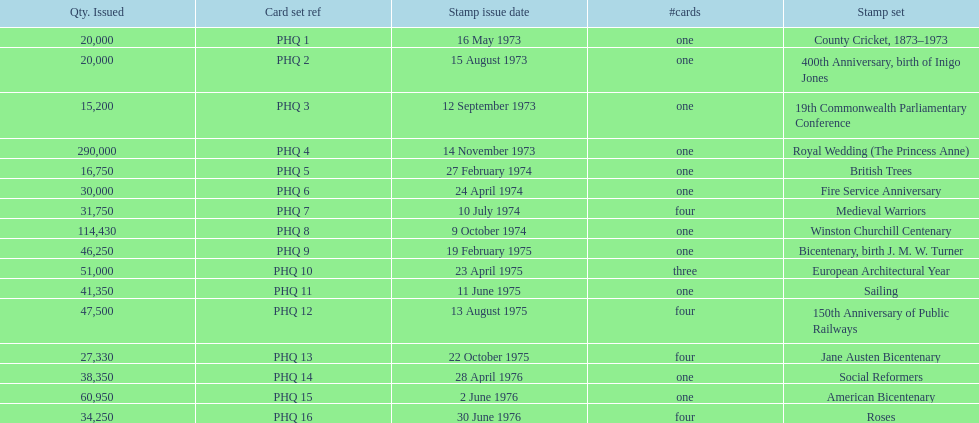Could you parse the entire table as a dict? {'header': ['Qty. Issued', 'Card set ref', 'Stamp issue date', '#cards', 'Stamp set'], 'rows': [['20,000', 'PHQ 1', '16 May 1973', 'one', 'County Cricket, 1873–1973'], ['20,000', 'PHQ 2', '15 August 1973', 'one', '400th Anniversary, birth of Inigo Jones'], ['15,200', 'PHQ 3', '12 September 1973', 'one', '19th Commonwealth Parliamentary Conference'], ['290,000', 'PHQ 4', '14 November 1973', 'one', 'Royal Wedding (The Princess Anne)'], ['16,750', 'PHQ 5', '27 February 1974', 'one', 'British Trees'], ['30,000', 'PHQ 6', '24 April 1974', 'one', 'Fire Service Anniversary'], ['31,750', 'PHQ 7', '10 July 1974', 'four', 'Medieval Warriors'], ['114,430', 'PHQ 8', '9 October 1974', 'one', 'Winston Churchill Centenary'], ['46,250', 'PHQ 9', '19 February 1975', 'one', 'Bicentenary, birth J. M. W. Turner'], ['51,000', 'PHQ 10', '23 April 1975', 'three', 'European Architectural Year'], ['41,350', 'PHQ 11', '11 June 1975', 'one', 'Sailing'], ['47,500', 'PHQ 12', '13 August 1975', 'four', '150th Anniversary of Public Railways'], ['27,330', 'PHQ 13', '22 October 1975', 'four', 'Jane Austen Bicentenary'], ['38,350', 'PHQ 14', '28 April 1976', 'one', 'Social Reformers'], ['60,950', 'PHQ 15', '2 June 1976', 'one', 'American Bicentenary'], ['34,250', 'PHQ 16', '30 June 1976', 'four', 'Roses']]} Which stamp set had only three cards in the set? European Architectural Year. 